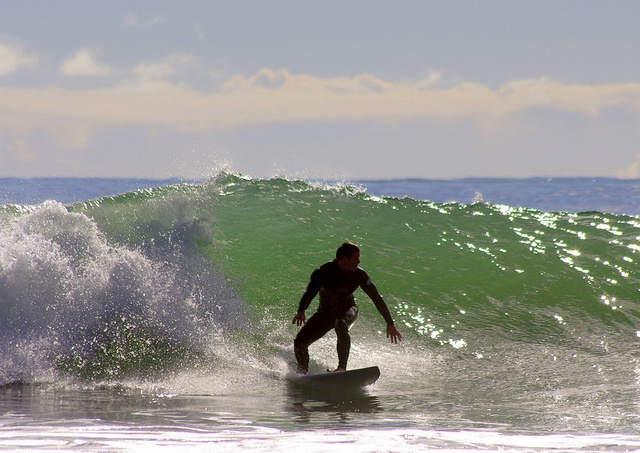Describe the objects in this image and their specific colors. I can see people in darkgray, black, gray, and darkgreen tones and surfboard in darkgray, black, and gray tones in this image. 